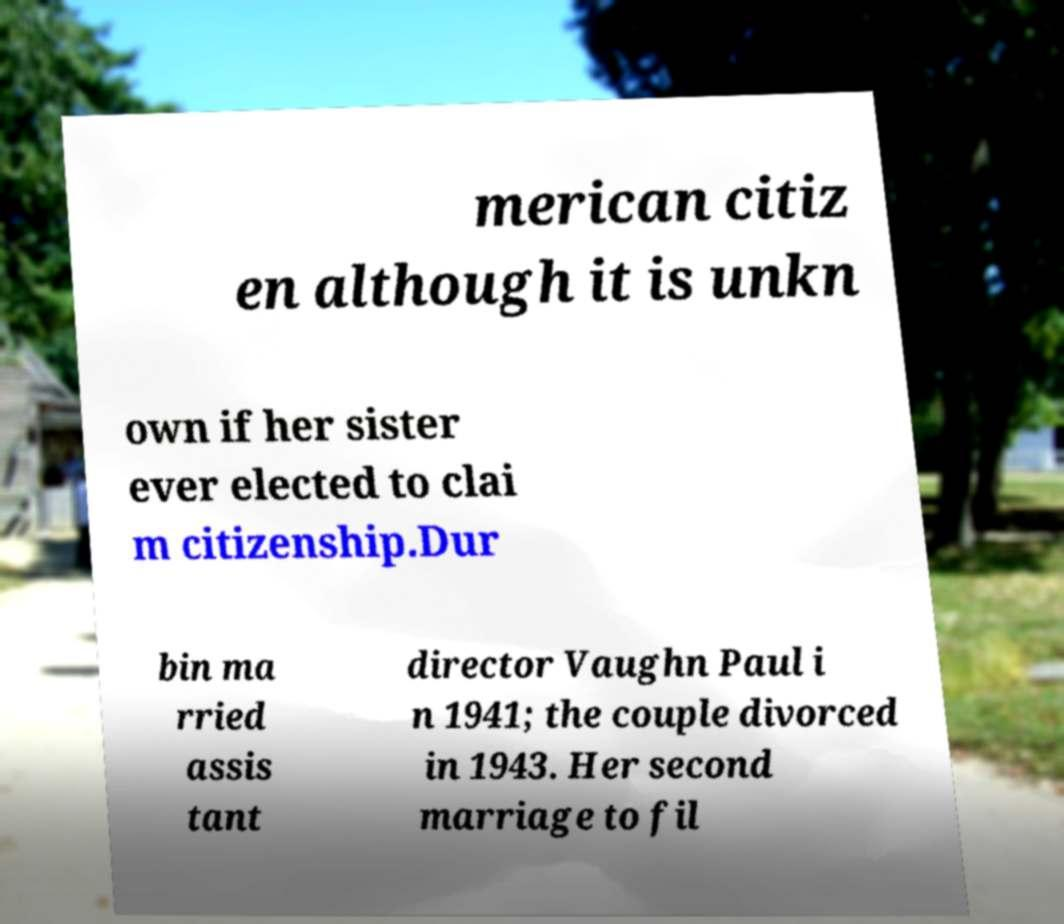Please read and relay the text visible in this image. What does it say? merican citiz en although it is unkn own if her sister ever elected to clai m citizenship.Dur bin ma rried assis tant director Vaughn Paul i n 1941; the couple divorced in 1943. Her second marriage to fil 